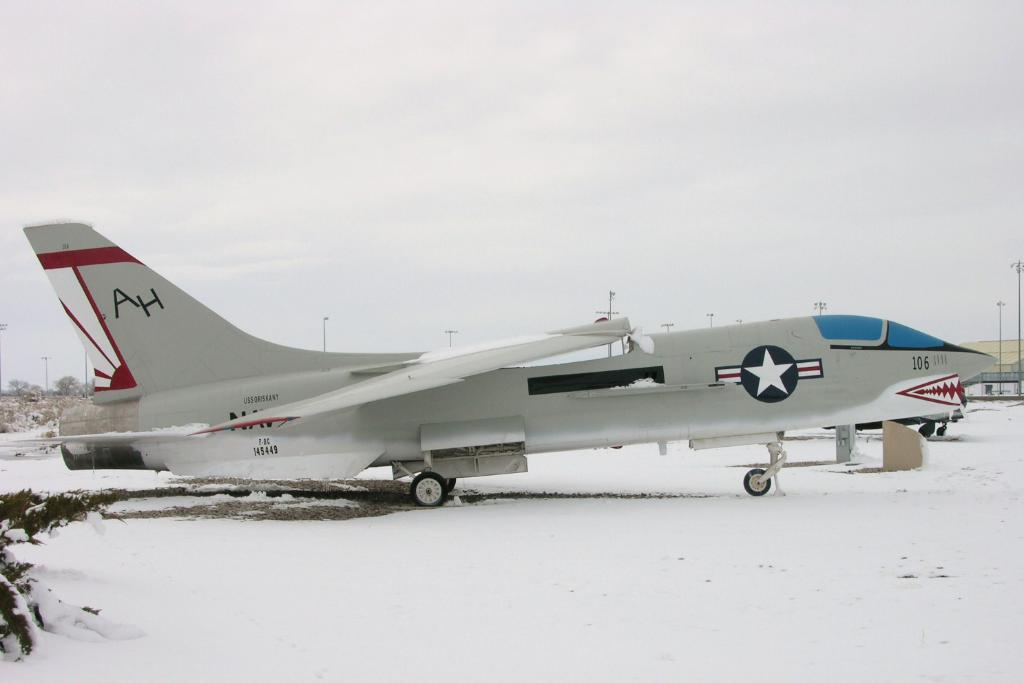Provide a one-sentence caption for the provided image. The initials AH are seen on the tail section of a gray, red and black military aircraft. 